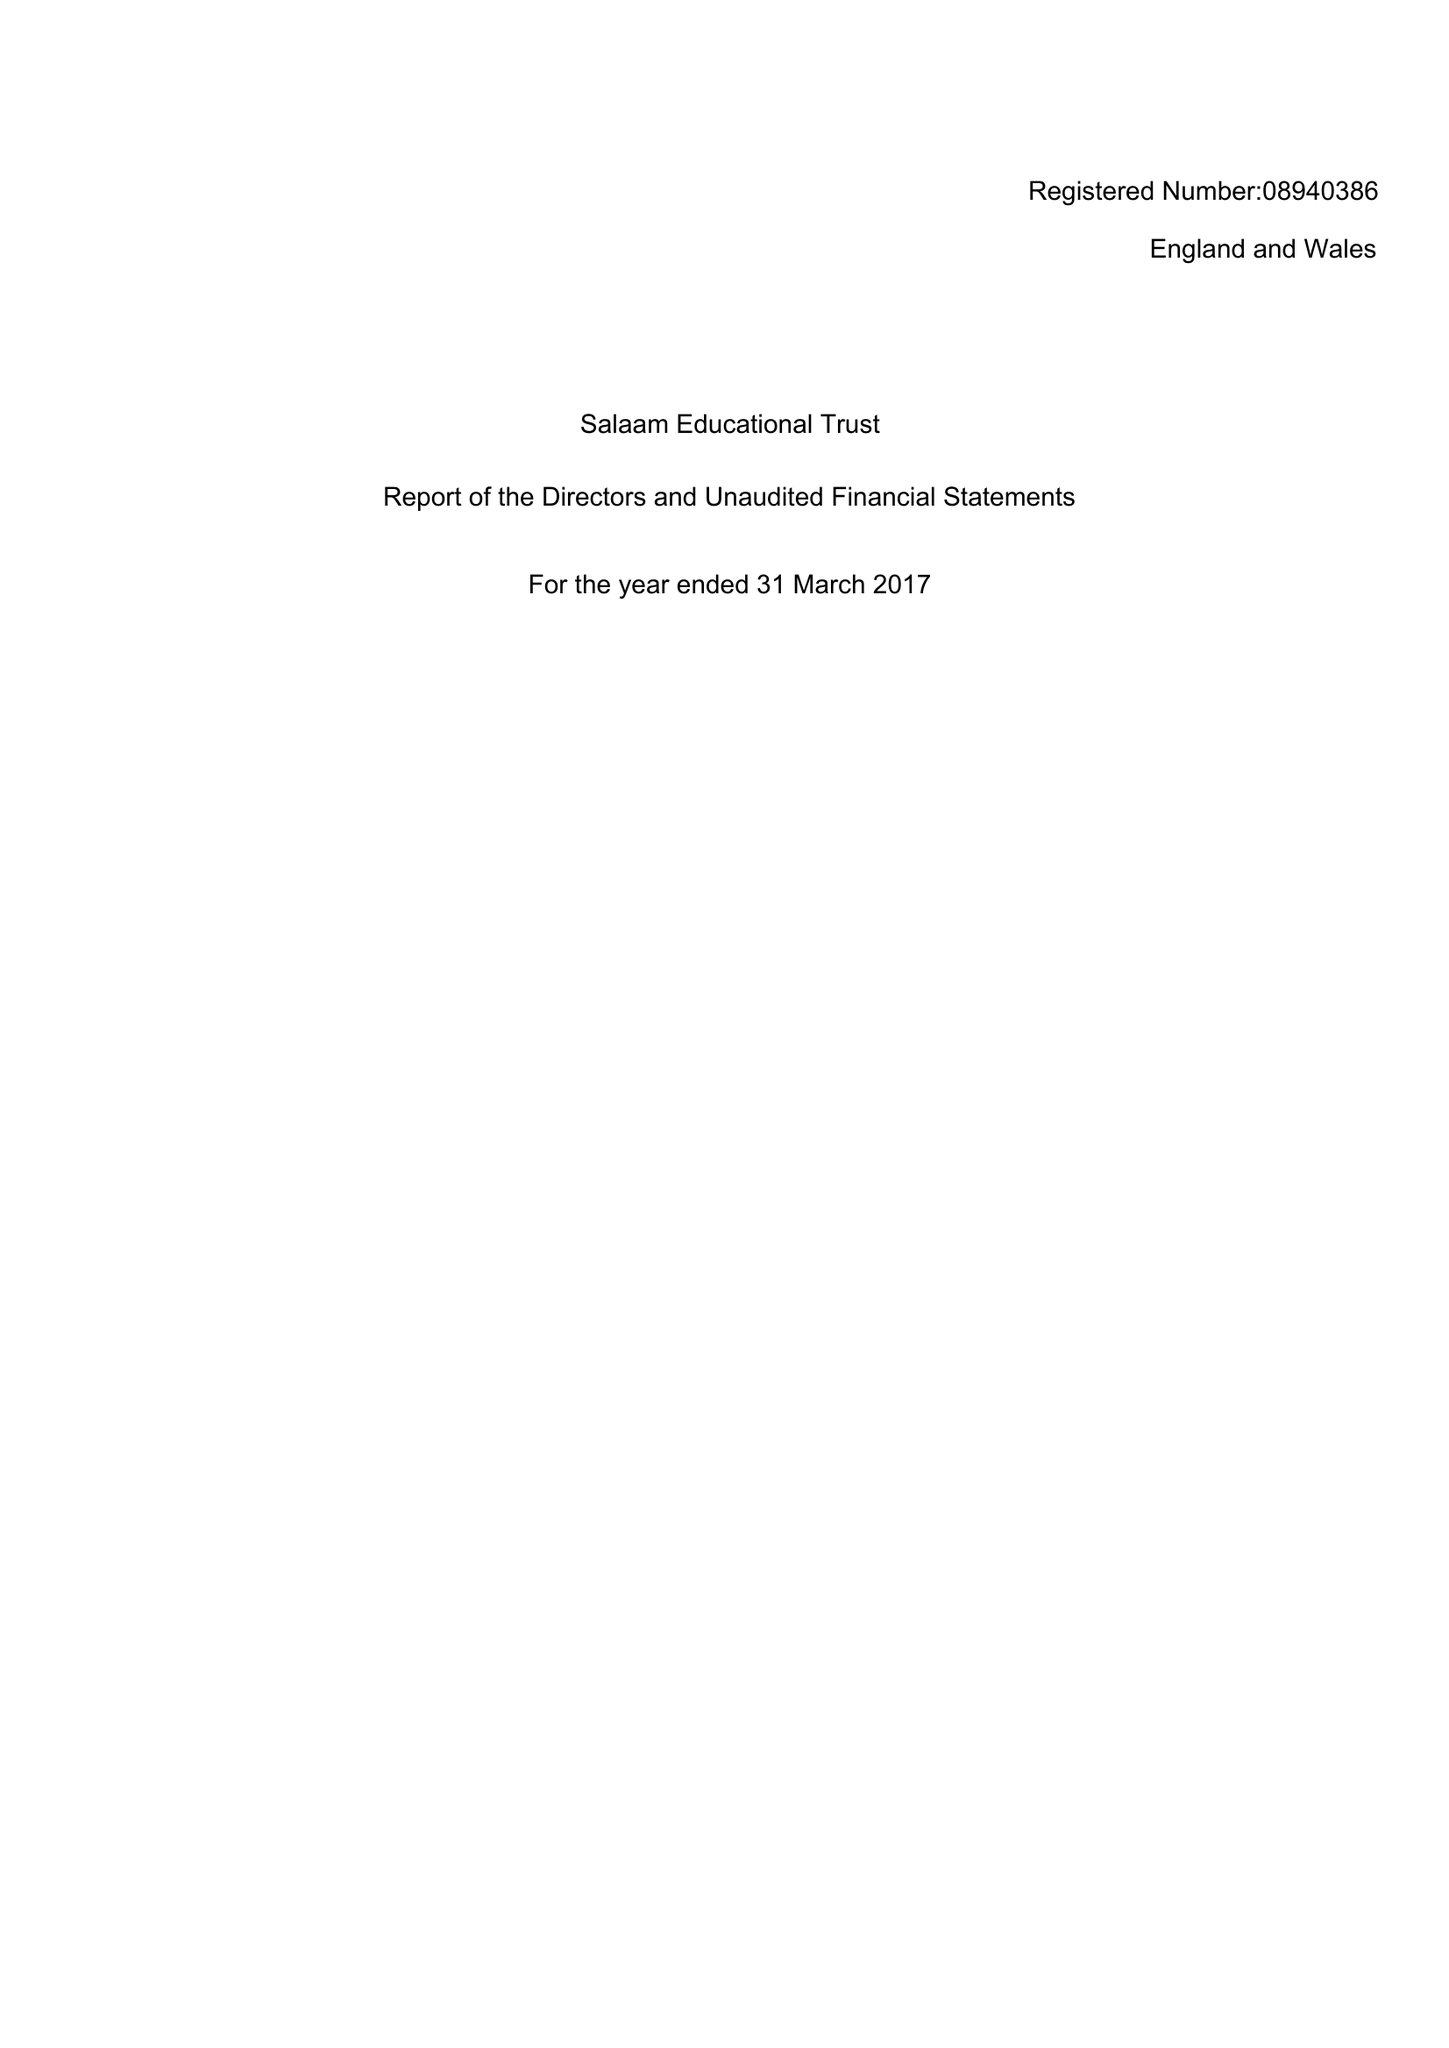What is the value for the income_annually_in_british_pounds?
Answer the question using a single word or phrase. 28316.00 